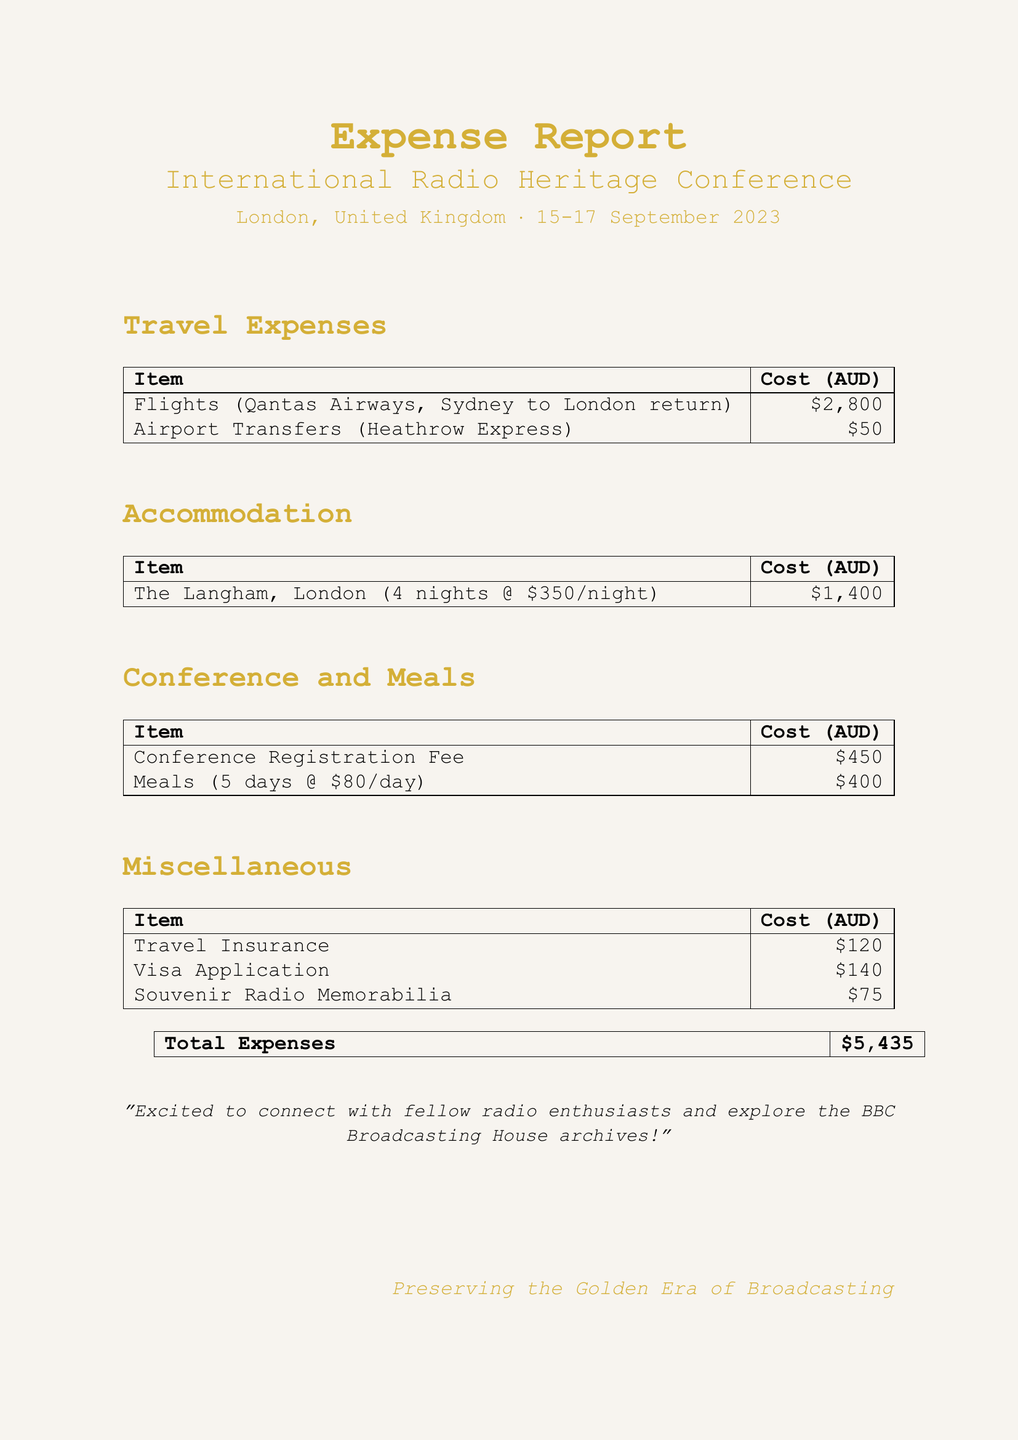What is the name of the conference? The name of the conference is mentioned in the document under conference details.
Answer: International Radio Heritage Conference What is the location of the conference? The location of the conference is provided in the conference details.
Answer: London, United Kingdom What is the total cost of flights? The total cost of flights is specified under travel expenses.
Answer: 2800 How many nights was the accommodation booked for? The number of nights for accommodation is found in the accommodation section.
Answer: 4 What is the total cost for meals? The total cost for meals can be calculated from the provided daily allowance and total days in the meals section.
Answer: 400 What is the total expenses amount? The total expenses can be found at the end of the document, summarizing all costs.
Answer: 5435 What kind of items are included in miscellaneous expenses? The miscellaneous section includes various costs that do not fit into other categories.
Answer: Travel Insurance, Visa Application, Souvenir Radio Memorabilia What is the registration fee amount for the conference? The registration fee is clearly stated in the conference section.
Answer: 450 What is the daily allowance for meals? The daily allowance is mentioned in the meals section of the document.
Answer: 80 